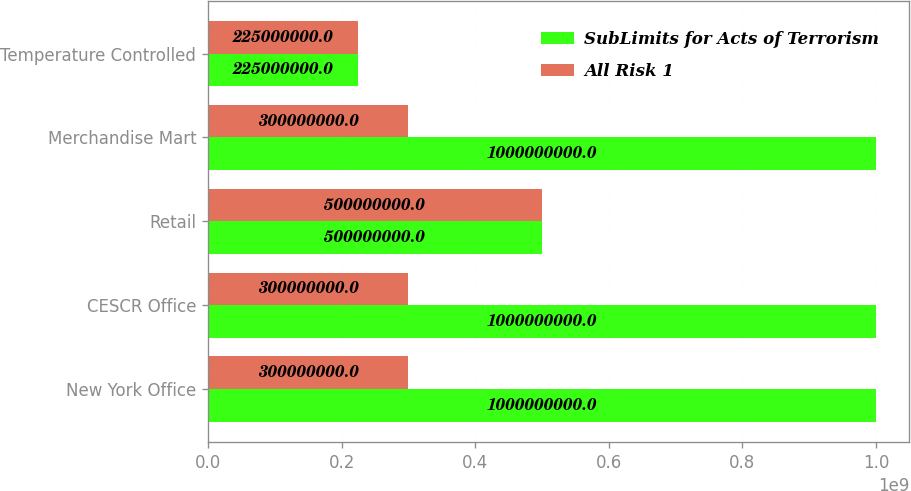Convert chart. <chart><loc_0><loc_0><loc_500><loc_500><stacked_bar_chart><ecel><fcel>New York Office<fcel>CESCR Office<fcel>Retail<fcel>Merchandise Mart<fcel>Temperature Controlled<nl><fcel>SubLimits for Acts of Terrorism<fcel>1e+09<fcel>1e+09<fcel>5e+08<fcel>1e+09<fcel>2.25e+08<nl><fcel>All Risk 1<fcel>3e+08<fcel>3e+08<fcel>5e+08<fcel>3e+08<fcel>2.25e+08<nl></chart> 